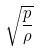Convert formula to latex. <formula><loc_0><loc_0><loc_500><loc_500>\sqrt { \frac { p } { \rho } }</formula> 